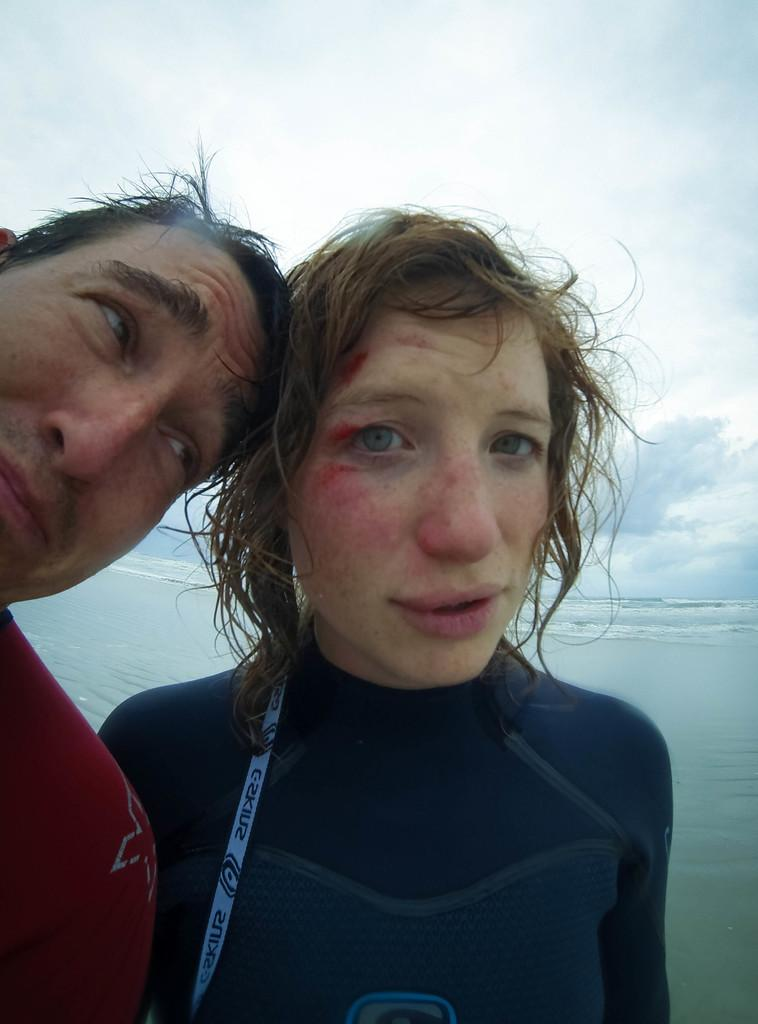Who or what can be seen in the front of the image? There are persons in the front of the image. What natural feature is visible in the background of the image? There is an ocean in the background of the image. What is the condition of the sky in the image? The sky is cloudy in the image. What is the limit of the answers that can be provided in the image? There is no limit to the answers that can be provided in the image, as it is a visual representation and not a source of information or answers. 